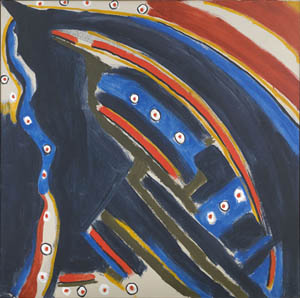How might this image relate to modern life and human experiences? This abstract image can be seen as a metaphor for modern life and human experiences. The deep blue and black background could represent the often overwhelming nature of contemporary existence, filled with uncertainties and challenges. The bold and intricate shapes in white highlight the distinct paths individuals carve out for themselves amidst the chaos, emphasizing personal identity and determination. The scattered red, yellow, and white dots symbolize moments of joy, accomplishment, and the small but significant experiences that light up our lives. In this interpretation, the image captures the blend of struggle and beauty inherent in the human condition, encouraging viewers to reflect on their own journeys and the unique tapestry of their lives. In the hustle and bustle of everyday life, often marked by deep contemplation and tumultuous emotions, this image resonates as an abstract representation of our personal battles and triumphs. Its mixture of stark contrasts and vibrant highlights can evoke a sense of recognition in viewers, reflecting on their own moments of doubt and clarity, struggle and success. It acts as a mirror, prompting us to find meaning and beauty even in complexity and disorder. 